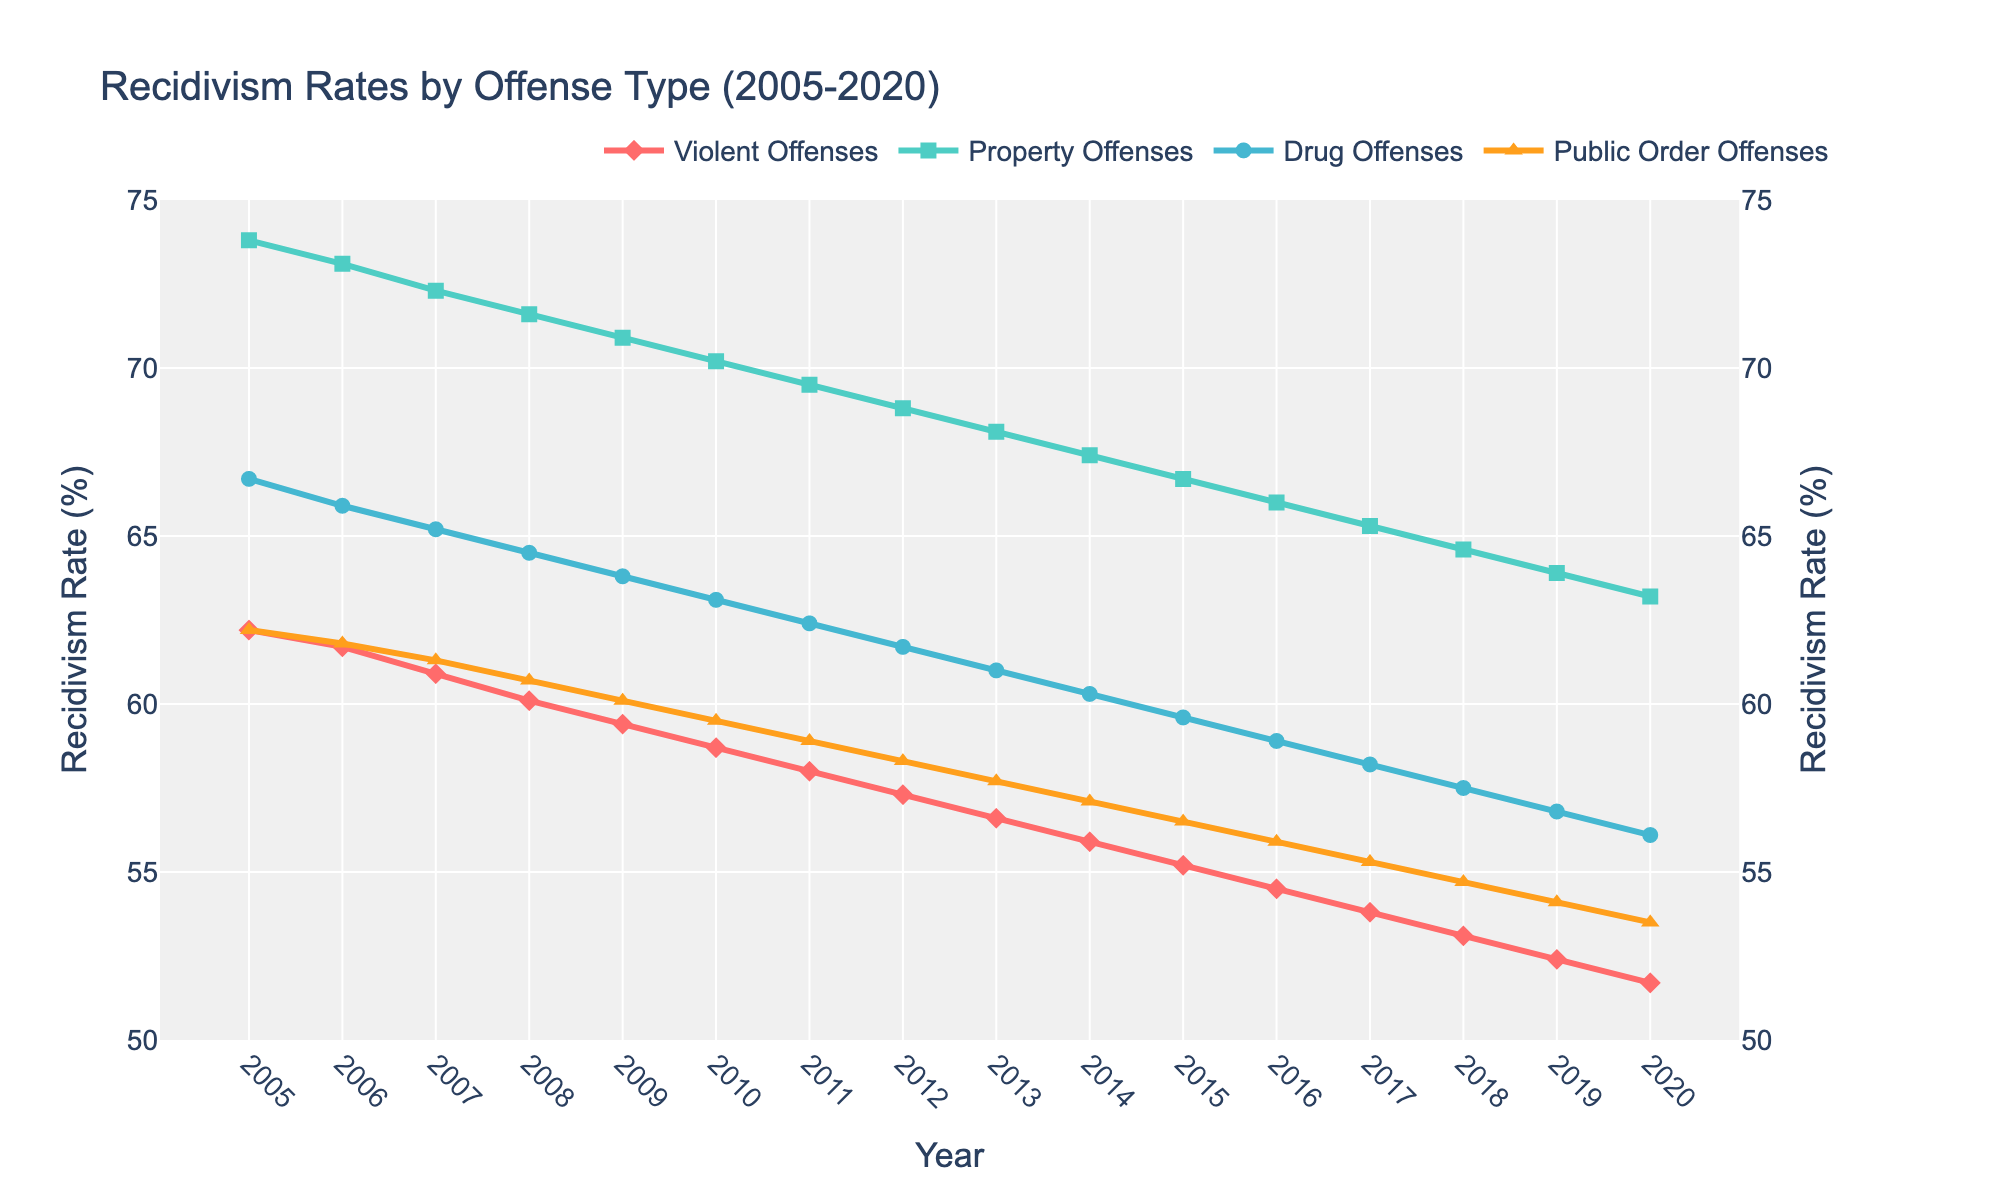What is the recidivism rate for Violent Offenses in 2005? To find the recidivism rate for Violent Offenses in 2005, look at the point on the graph corresponding to 'Violent Offenses' (red markers) in the year 2005. The label indicates it is 62.2%.
Answer: 62.2% Which offense type showed the highest recidivism rate in 2010? Observe the values for all offense types in 2010. Compare the positions of the markers on the y-axis: 'Property Offenses' (green markers) indicates the highest rate which is 70.2%.
Answer: Property Offenses How did the recidivism rate for Drug Offenses change from 2005 to 2015? Note the rate for Drug Offenses (blue markers) in both 2005 and 2015. In 2005, it was 66.7%, and in 2015 it was 59.6%. The change is a decrease of (66.7 - 59.6) = 7.1%.
Answer: Decreased by 7.1% What is the average recidivism rate for Public Order Offenses over the provided years? Sum the recidivism rates for Public Order Offenses (orange markers) from 2005 to 2020 and divide by the number of years. The sum is (62.2 + 61.8 + 61.3 + 60.7 + 60.1 + 59.5 + 58.9 + 58.3 + 57.7 + 57.1 + 56.5 + 55.9 + 55.3 + 54.7 + 54.1 + 53.5) = 935.5; the average is 935.5/16 ≈ 58.47%.
Answer: 58.47% Between which pairs of consecutive years did Property Offenses see the highest absolute drop in recidivism rate? Calculate the absolute differences in recidivism rates for Property Offenses (green markers) between each pair of consecutive years and find the highest one. The largest drop is between 2010 (70.2%) and 2011 (69.5%) which is an absolute drop of 0.7%.
Answer: 2010 to 2011 Which offense type has the least decline in recidivism rate from 2005 to 2020? Calculate the decline for each offense type by subtracting their rates in 2020 from 2005. For Violent Offenses: 62.2 - 51.7 = 10.5%; for Property Offenses: 73.8 - 63.2 = 10.6%; for Drug Offenses: 66.7 - 56.1 = 10.6%; for Public Order Offenses: 62.2 - 53.5 = 8.7%; The least decline is for 'Public Order Offenses'.
Answer: Public Order Offenses What is the visual pattern observed for the recidivism rate of Violent Offenses over the years? Observing the red markers over the years, we see a consistent downward trend indicating a decrease in recidivism rates from 2005 (62.2%) to 2020 (51.7%).
Answer: Downward trend 